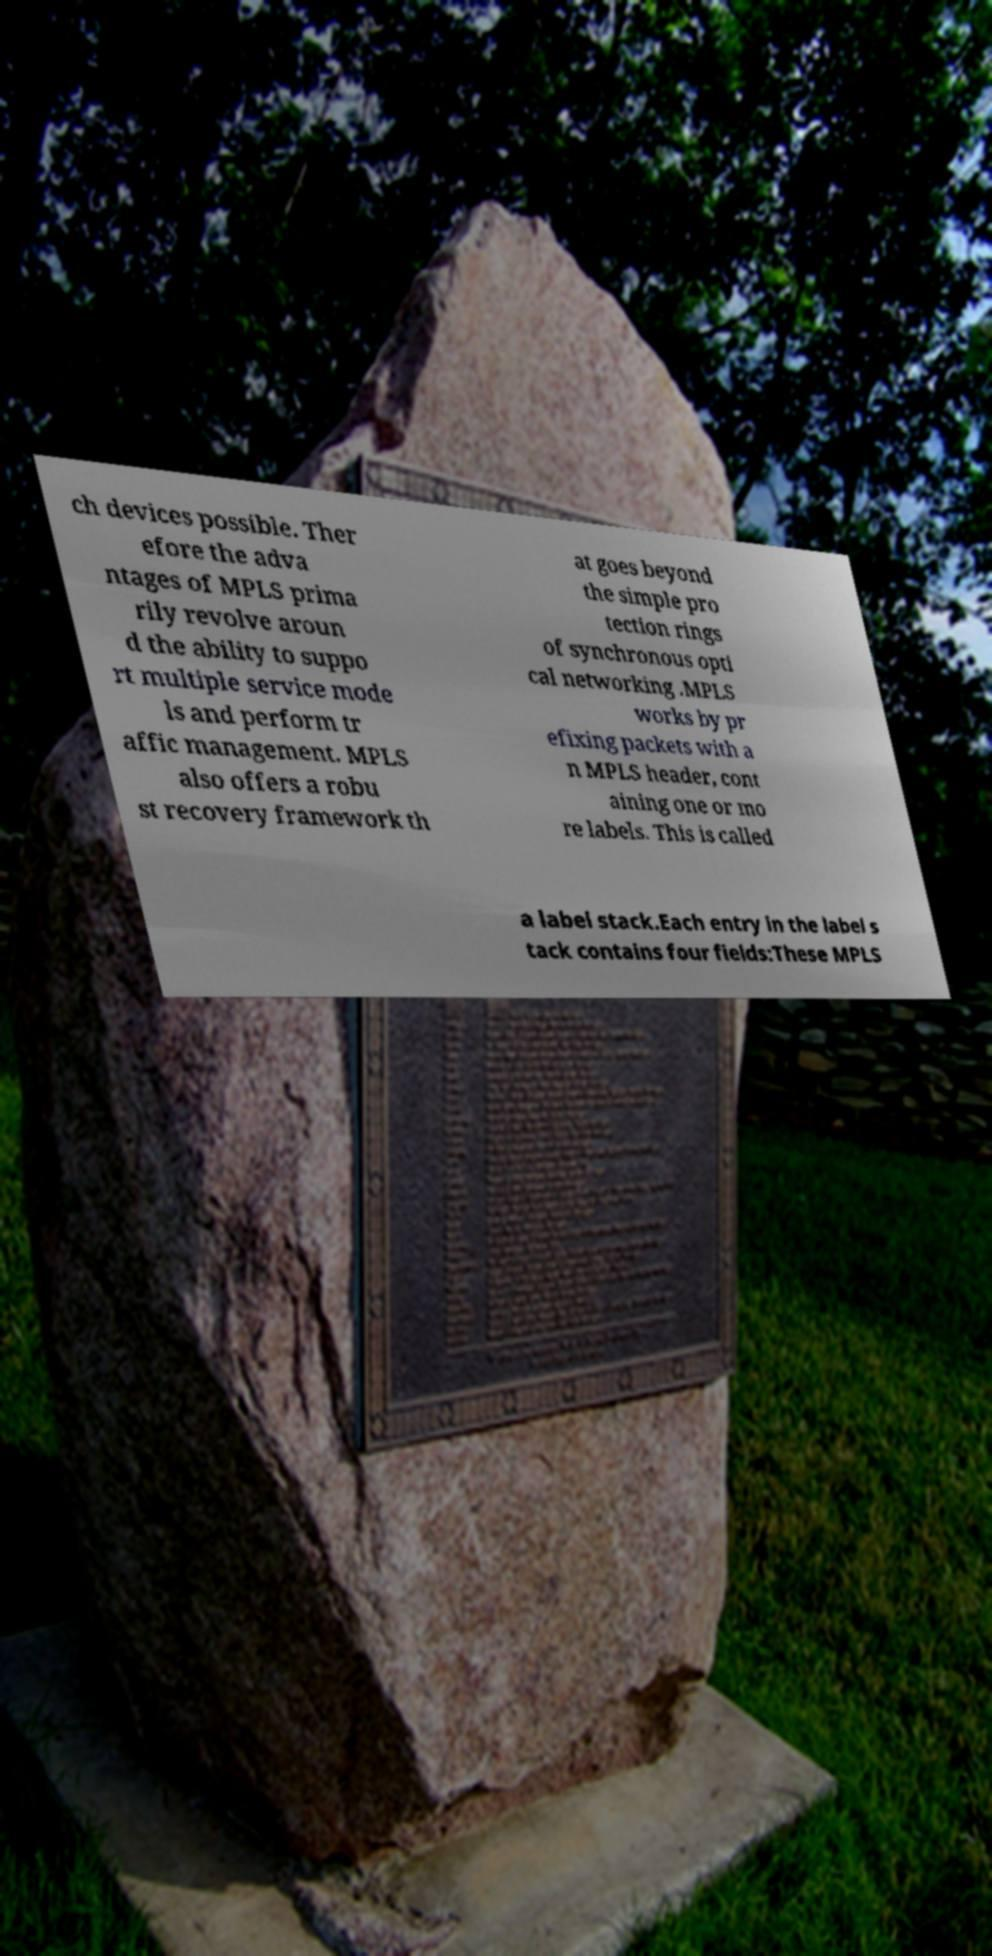Can you read and provide the text displayed in the image?This photo seems to have some interesting text. Can you extract and type it out for me? ch devices possible. Ther efore the adva ntages of MPLS prima rily revolve aroun d the ability to suppo rt multiple service mode ls and perform tr affic management. MPLS also offers a robu st recovery framework th at goes beyond the simple pro tection rings of synchronous opti cal networking .MPLS works by pr efixing packets with a n MPLS header, cont aining one or mo re labels. This is called a label stack.Each entry in the label s tack contains four fields:These MPLS 